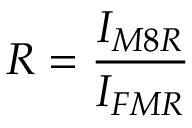Convert formula to latex. <formula><loc_0><loc_0><loc_500><loc_500>R = \frac { I _ { M 8 R } } { I _ { F M R } }</formula> 